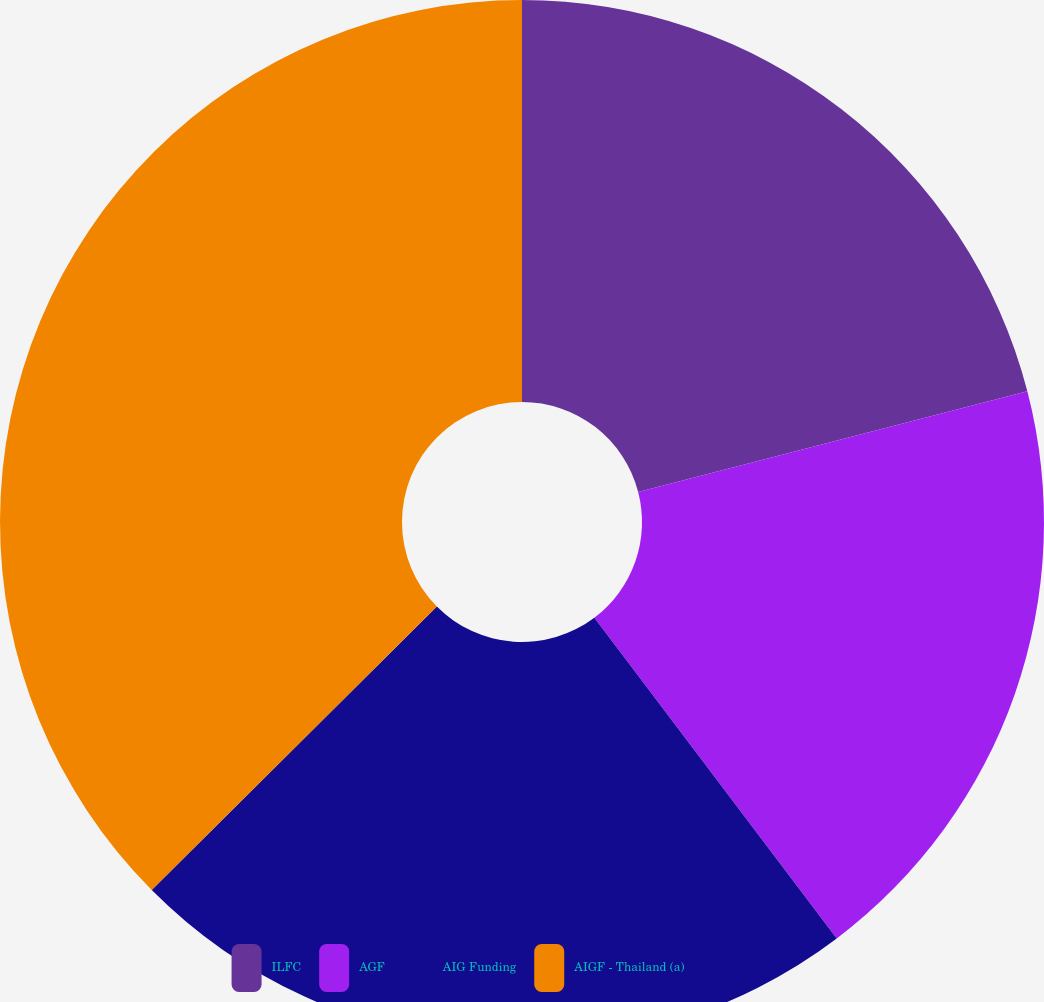Convert chart to OTSL. <chart><loc_0><loc_0><loc_500><loc_500><pie_chart><fcel>ILFC<fcel>AGF<fcel>AIG Funding<fcel>AIGF - Thailand (a)<nl><fcel>20.97%<fcel>18.73%<fcel>22.85%<fcel>37.45%<nl></chart> 